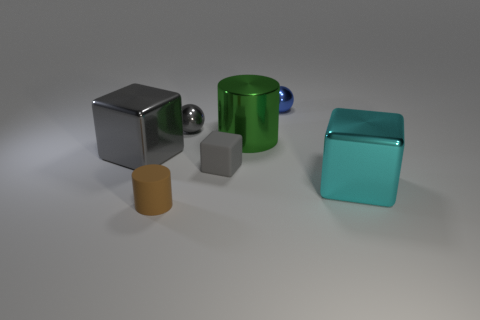Add 1 big gray cubes. How many objects exist? 8 Subtract all cylinders. How many objects are left? 5 Add 3 blue things. How many blue things are left? 4 Add 7 brown cylinders. How many brown cylinders exist? 8 Subtract 1 brown cylinders. How many objects are left? 6 Subtract all brown rubber objects. Subtract all large green things. How many objects are left? 5 